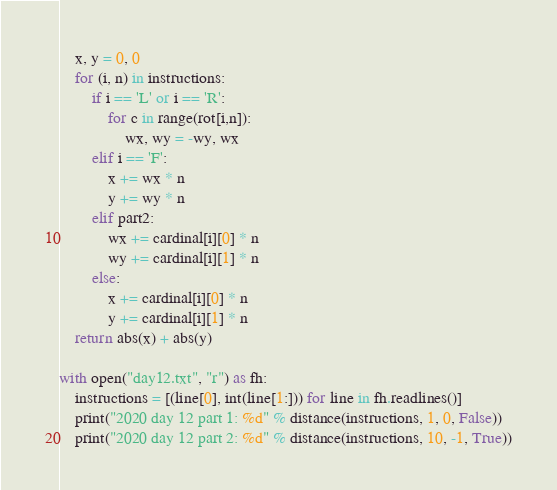Convert code to text. <code><loc_0><loc_0><loc_500><loc_500><_Python_>    x, y = 0, 0
    for (i, n) in instructions:
        if i == 'L' or i == 'R':
            for c in range(rot[i,n]):
                wx, wy = -wy, wx
        elif i == 'F':
            x += wx * n
            y += wy * n
        elif part2:
            wx += cardinal[i][0] * n
            wy += cardinal[i][1] * n
        else:
            x += cardinal[i][0] * n
            y += cardinal[i][1] * n
    return abs(x) + abs(y)

with open("day12.txt", "r") as fh:
    instructions = [(line[0], int(line[1:])) for line in fh.readlines()]
    print("2020 day 12 part 1: %d" % distance(instructions, 1, 0, False))
    print("2020 day 12 part 2: %d" % distance(instructions, 10, -1, True))


</code> 